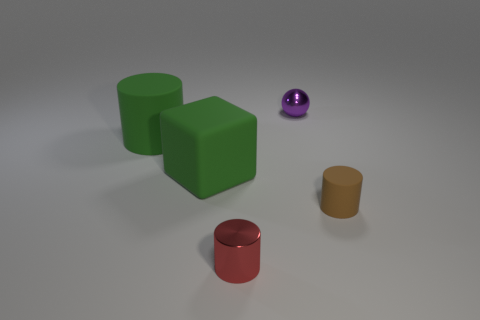How big is the cylinder to the right of the small cylinder that is left of the tiny matte cylinder?
Keep it short and to the point. Small. There is a big green object that is the same shape as the red object; what material is it?
Give a very brief answer. Rubber. How many purple spheres are there?
Your answer should be very brief. 1. There is a matte cylinder on the right side of the tiny thing behind the cylinder that is behind the brown cylinder; what color is it?
Your answer should be compact. Brown. Are there fewer small metal objects than small red metal things?
Ensure brevity in your answer.  No. There is another small object that is the same shape as the red shiny thing; what color is it?
Ensure brevity in your answer.  Brown. What color is the cylinder that is made of the same material as the tiny purple object?
Make the answer very short. Red. How many red metallic objects are the same size as the red metal cylinder?
Give a very brief answer. 0. What is the material of the cube?
Provide a short and direct response. Rubber. Is the number of small red objects greater than the number of large brown balls?
Offer a terse response. Yes. 